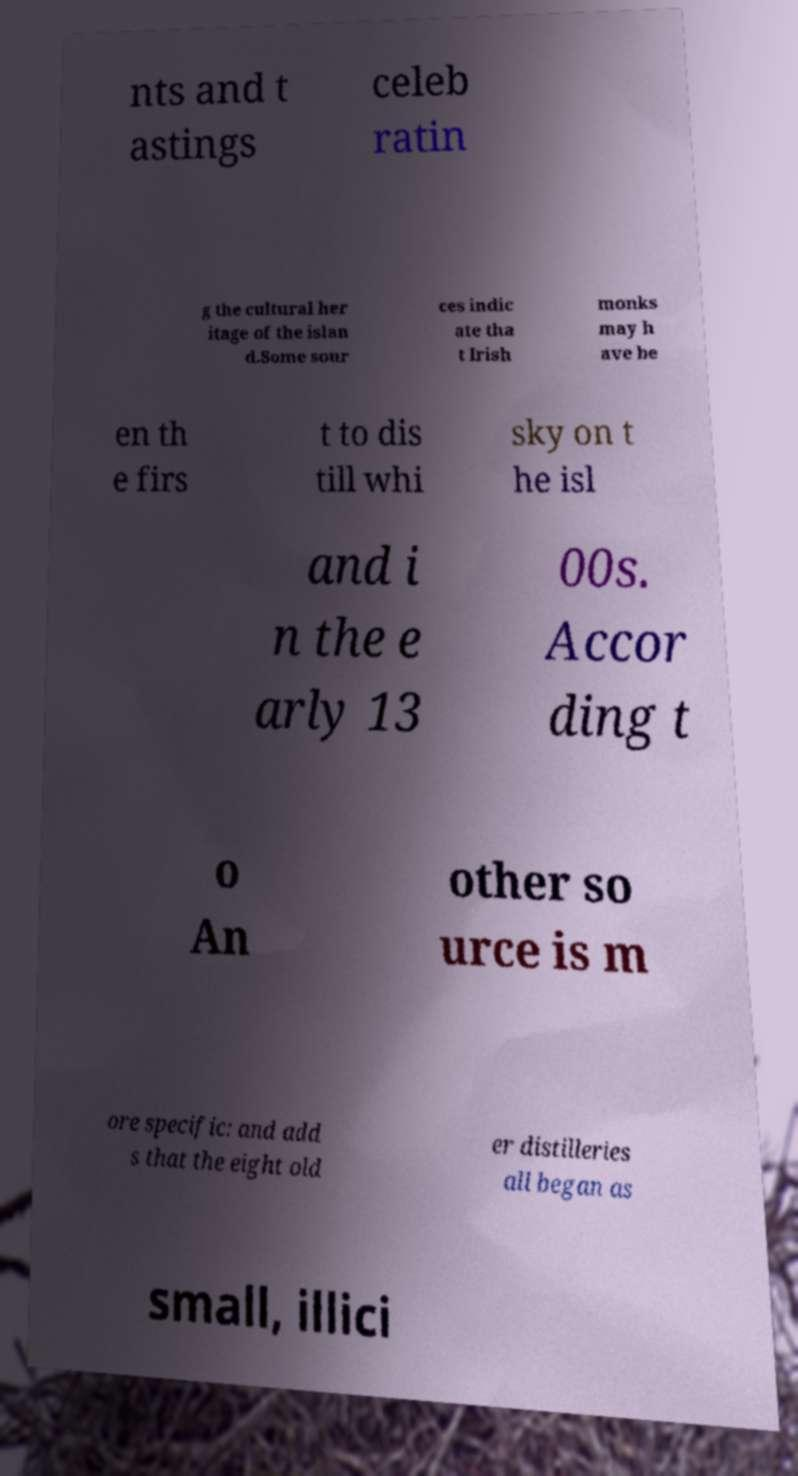What messages or text are displayed in this image? I need them in a readable, typed format. nts and t astings celeb ratin g the cultural her itage of the islan d.Some sour ces indic ate tha t Irish monks may h ave be en th e firs t to dis till whi sky on t he isl and i n the e arly 13 00s. Accor ding t o An other so urce is m ore specific: and add s that the eight old er distilleries all began as small, illici 